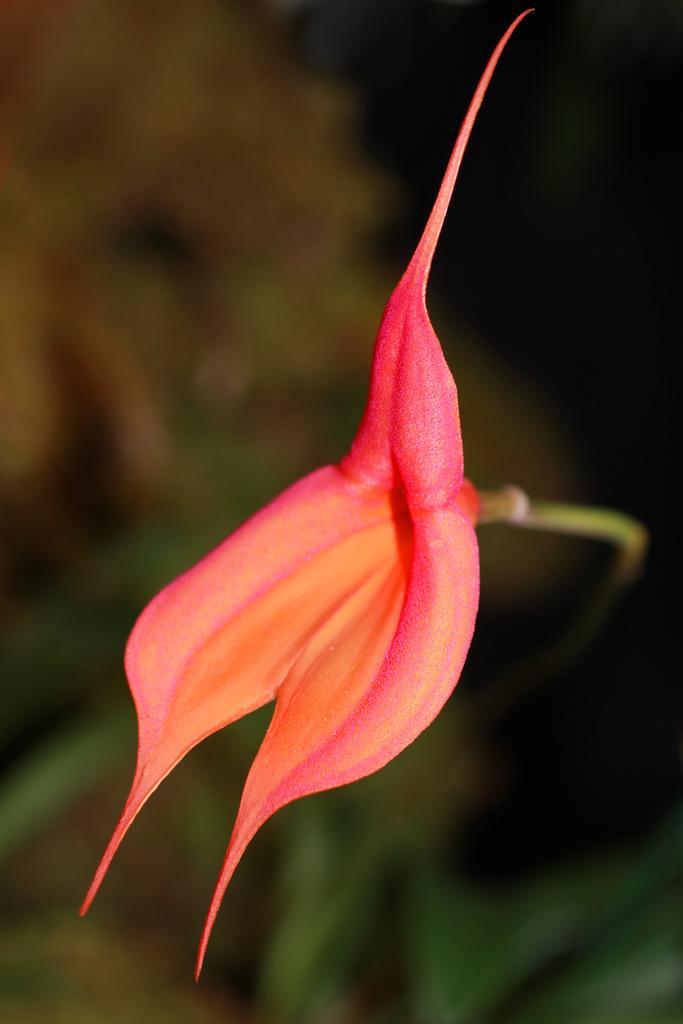Can you describe this image briefly? In this picture I can see there is a , it is in orange and pink color, it is attached to a stem and the backdrop is slightly blurred. 